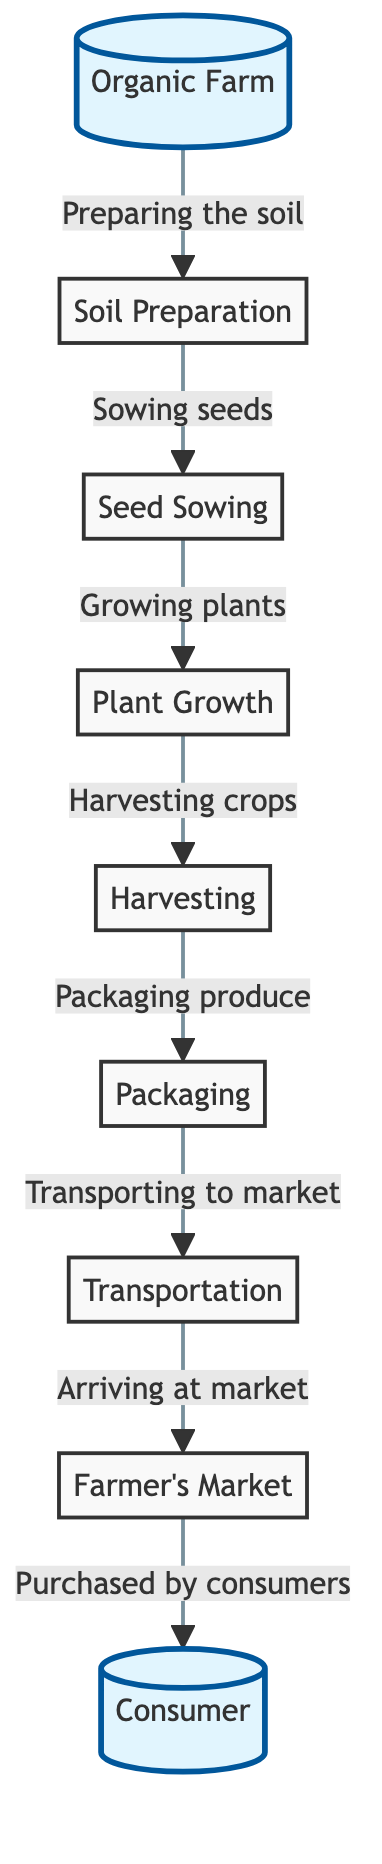What is the first step in this food chain? The first step shown in the diagram is "Soil Preparation," which is the foundational task before any seeds can be sown. It is directly connected to the "Organic Farm."
Answer: Soil Preparation How many nodes are in the diagram? By counting the nodes listed in the diagram, we find there are a total of 8 nodes: Organic Farm, Soil Preparation, Seed Sowing, Plant Growth, Harvesting, Packaging, Transportation, and Farmer's Market, culminating at the Consumer node.
Answer: 8 What is the last step before reaching the consumer? The last step before reaching the Consumer is "Purchased by consumers," which is the final action taken at the Farmer's Market node, indicating the completion of the flow from farm to table.
Answer: Purchased by consumers What is packaged after harvesting? After harvesting, the produce is packaged, which is a necessary step for ensuring that it is ready for sale at the market. This connection is clearly indicated following the harvesting node.
Answer: Produce What is the relationship between "Transporting to market" and "Arriving at market"? "Transporting to market" is an action that directly leads to "Arriving at market," illustrating the flow of goods from one stage of the process to the next within the food chain.
Answer: Leads to What is the main focus of this food chain diagram? The main focus of this food chain diagram is to illustrate the complete journey of organic vegetables from production at the Organic Farm through various stages until they reach the Consumer.
Answer: The journey of organic vegetables Which farming activity comes immediately after soil preparation? Immediately following soil preparation is the activity of seed sowing, which represents the next logical step in the process of cultivating organic vegetables. This sequential connection is evident in the diagram.
Answer: Seed Sowing How does the organic produce reach the consumer? The organic produce reaches the consumer through a sequence of processes: it is harvested, packaged, transported to the market, and finally purchased by the consumer. Each of these steps contributes to the overall flow displayed in the diagram.
Answer: Through purchasing at the market 